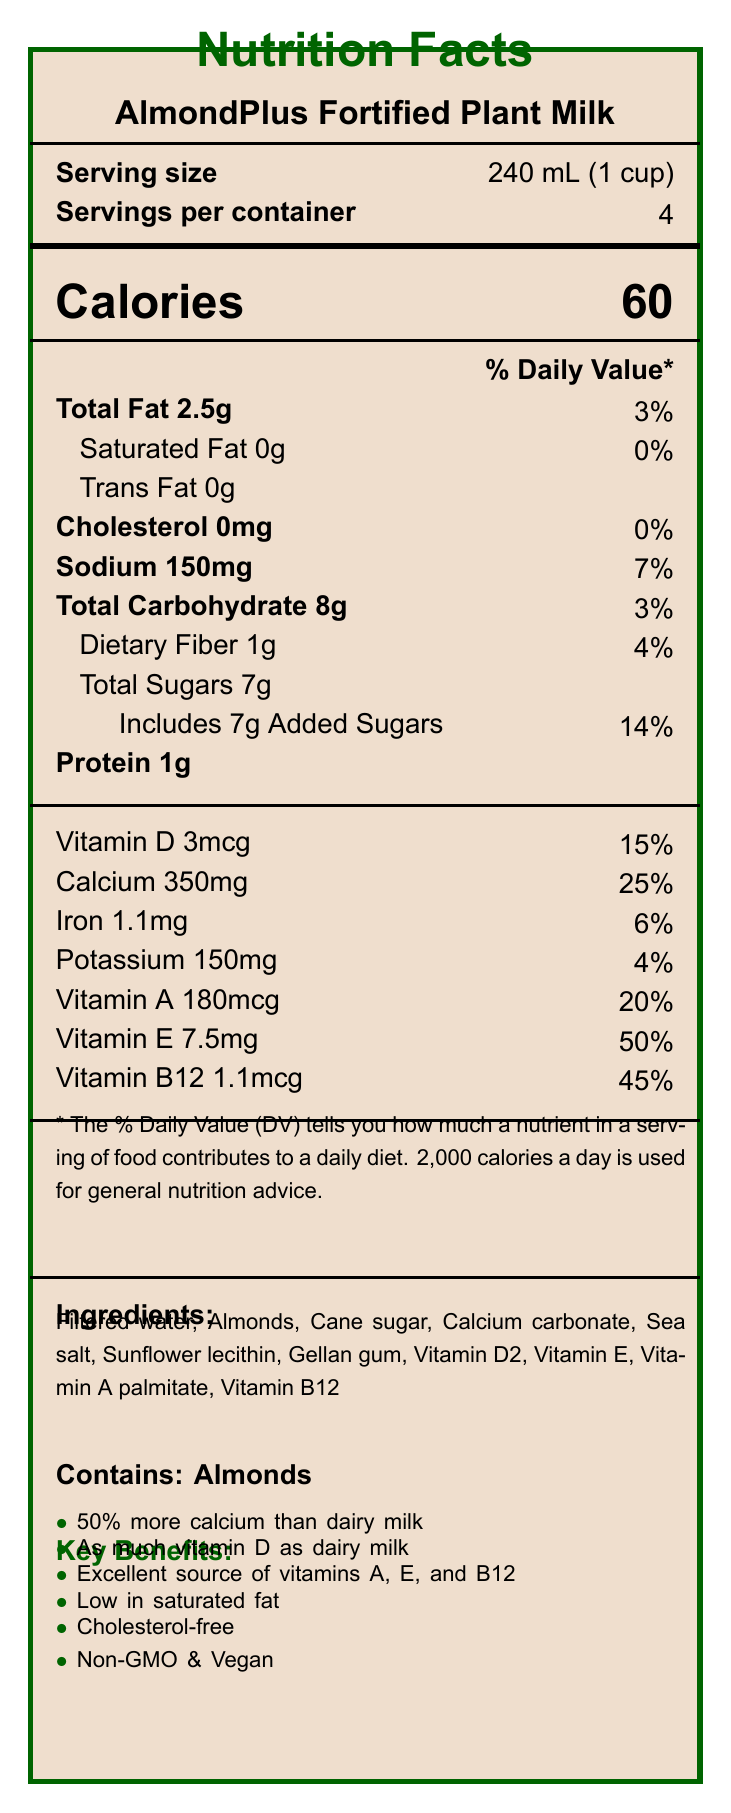what is the serving size? The serving size is specified in the document as "240 mL (1 cup)".
Answer: 240 mL (1 cup) how many calories are in one serving of AlmondPlus Fortified Plant Milk? The document lists the calories per serving as 60.
Answer: 60 what percentage of daily value is the calcium content per serving? According to the document, the calcium content per serving is 350mg, which corresponds to 25% of the daily value.
Answer: 25% what is the amount of vitamin D in each serving? The document states that each serving contains 3mcg of vitamin D.
Answer: 3mcg which ingredient is mentioned first in the ingredient list? The first ingredient in the list is Filtered water.
Answer: Filtered water what is the total fat content per serving? The document shows that the total fat content per serving is 2.5g.
Answer: 2.5g how much sodium does one serving contain? The sodium content per serving is listed as 150mg.
Answer: 150mg what statement about calcium is mentioned in the key benefits section? The key benefits section mentions that the product contains "50% more calcium than dairy milk".
Answer: 50% more calcium than dairy milk which vitamins are highlighted as an excellent source in the marketing claims? The marketing claims state that the product is an excellent source of vitamins A, E, and B12.
Answer: Vitamins A, E, and B12 what is the packaging material used for this product? A. Plastic B. Glass C. Recyclable carton D. Metal The sustainability info section specifies that the packaging is a "100% recyclable carton".
Answer: C. Recyclable carton AlmondPlus Fortified Plant Milk has ___ grams of added sugars per serving. A. 4 B. 5 C. 6 D. 7 The document lists "Includes 7g Added Sugars", so the answer is 7 grams of added sugars per serving.
Answer: D. 7 is this product suitable for vegans? The marketing claims clearly state that the product is "Vegan".
Answer: Yes compare the calcium content of this plant milk to that of dairy milk. The comparison section lists calcium content as "350mg vs 300mg in dairy milk".
Answer: The plant milk contains 50mg more calcium per serving than dairy milk, which usually has 300mg. summarize the key nutritional benefits of AlmondPlus Fortified Plant Milk. The document highlights the nutritional benefits including higher calcium, equivalent vitamin D, and being rich in specific vitamins along with other health and diet claims.
Answer: AlmondPlus Fortified Plant Milk offers 50% more calcium than dairy milk, as much vitamin D as dairy milk, and is an excellent source of vitamins A, E, and B12. It is low in saturated fat, cholesterol-free, non-GMO, and vegan. which vitamin has the highest percentage of daily value in this product? The document states Vitamin E has 50% of the daily value which is the highest percentage given.
Answer: Vitamin E with 50% what is the daily value percentage for added sugars? The daily value percentage for added sugars is listed as 14% in the document.
Answer: 14% how does the carbon footprint of AlmondPlus compare to dairy milk? The sustainability info section claims a "60% lower than dairy milk production".
Answer: 60% lower what percentage of daily value does sodium contribute? The sodium content per serving represents 7% of the daily value according to the document.
Answer: 7% how much protein does one serving provide? The document states each serving provides 1g of protein.
Answer: 1g is there information on the environmental impact of growing almonds? The document does not provide details on the environmental impact of growing almonds, only on packaging and carbon footprint.
Answer: Not enough information what is the main target audience for AlmondPlus Fortified Plant Milk? The retail strategy section identifies these groups as the main target audience.
Answer: Health-conscious consumers, lactose-intolerant individuals, and eco-friendly shoppers 